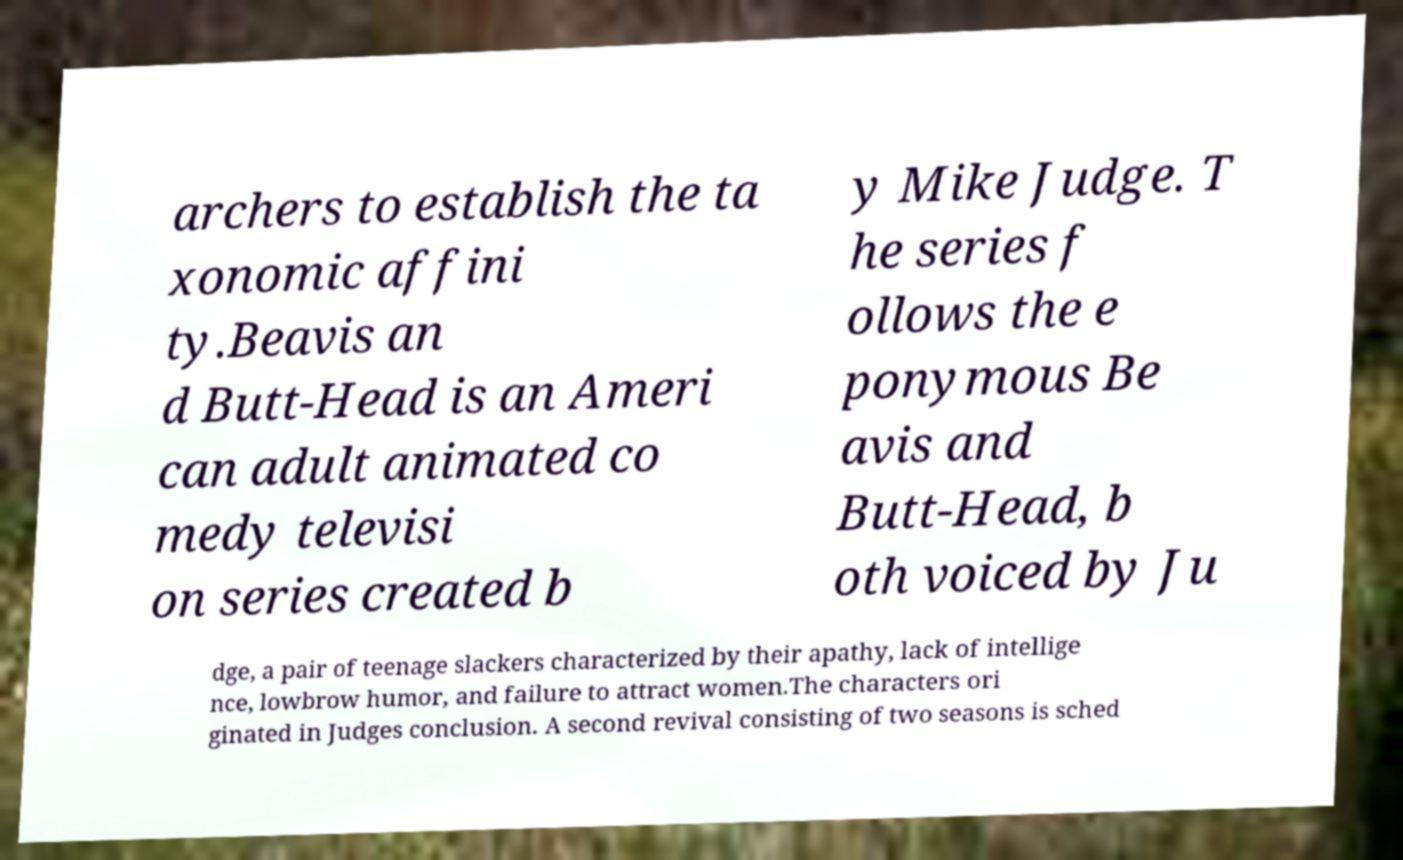For documentation purposes, I need the text within this image transcribed. Could you provide that? archers to establish the ta xonomic affini ty.Beavis an d Butt-Head is an Ameri can adult animated co medy televisi on series created b y Mike Judge. T he series f ollows the e ponymous Be avis and Butt-Head, b oth voiced by Ju dge, a pair of teenage slackers characterized by their apathy, lack of intellige nce, lowbrow humor, and failure to attract women.The characters ori ginated in Judges conclusion. A second revival consisting of two seasons is sched 